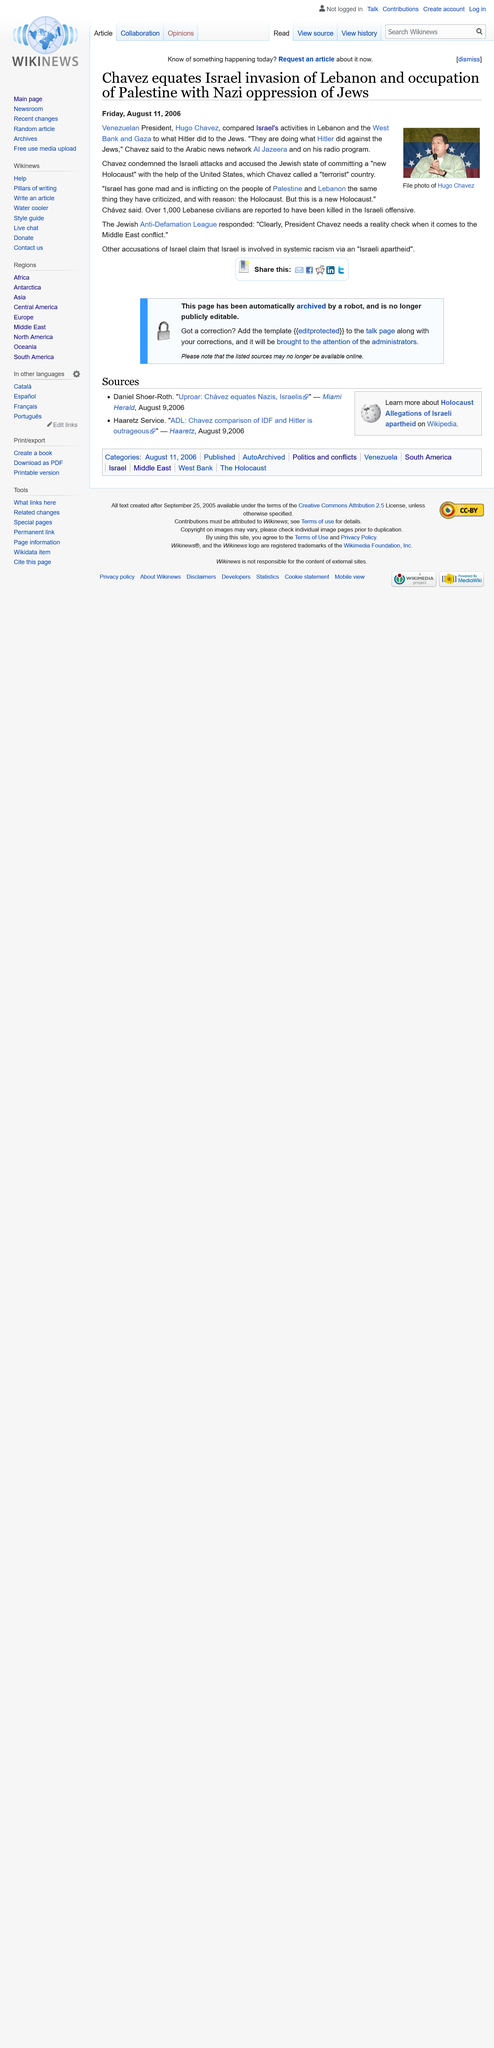Specify some key components in this picture. The Israeli offensive has resulted in over 1000 Lebanese civilians being killed, with many more injured and displaced. The Venezuelan President referred to the United States as a "terrorist" country on his radio program. The term given to the treatment of Jews by Hitler is the Holocaust. 